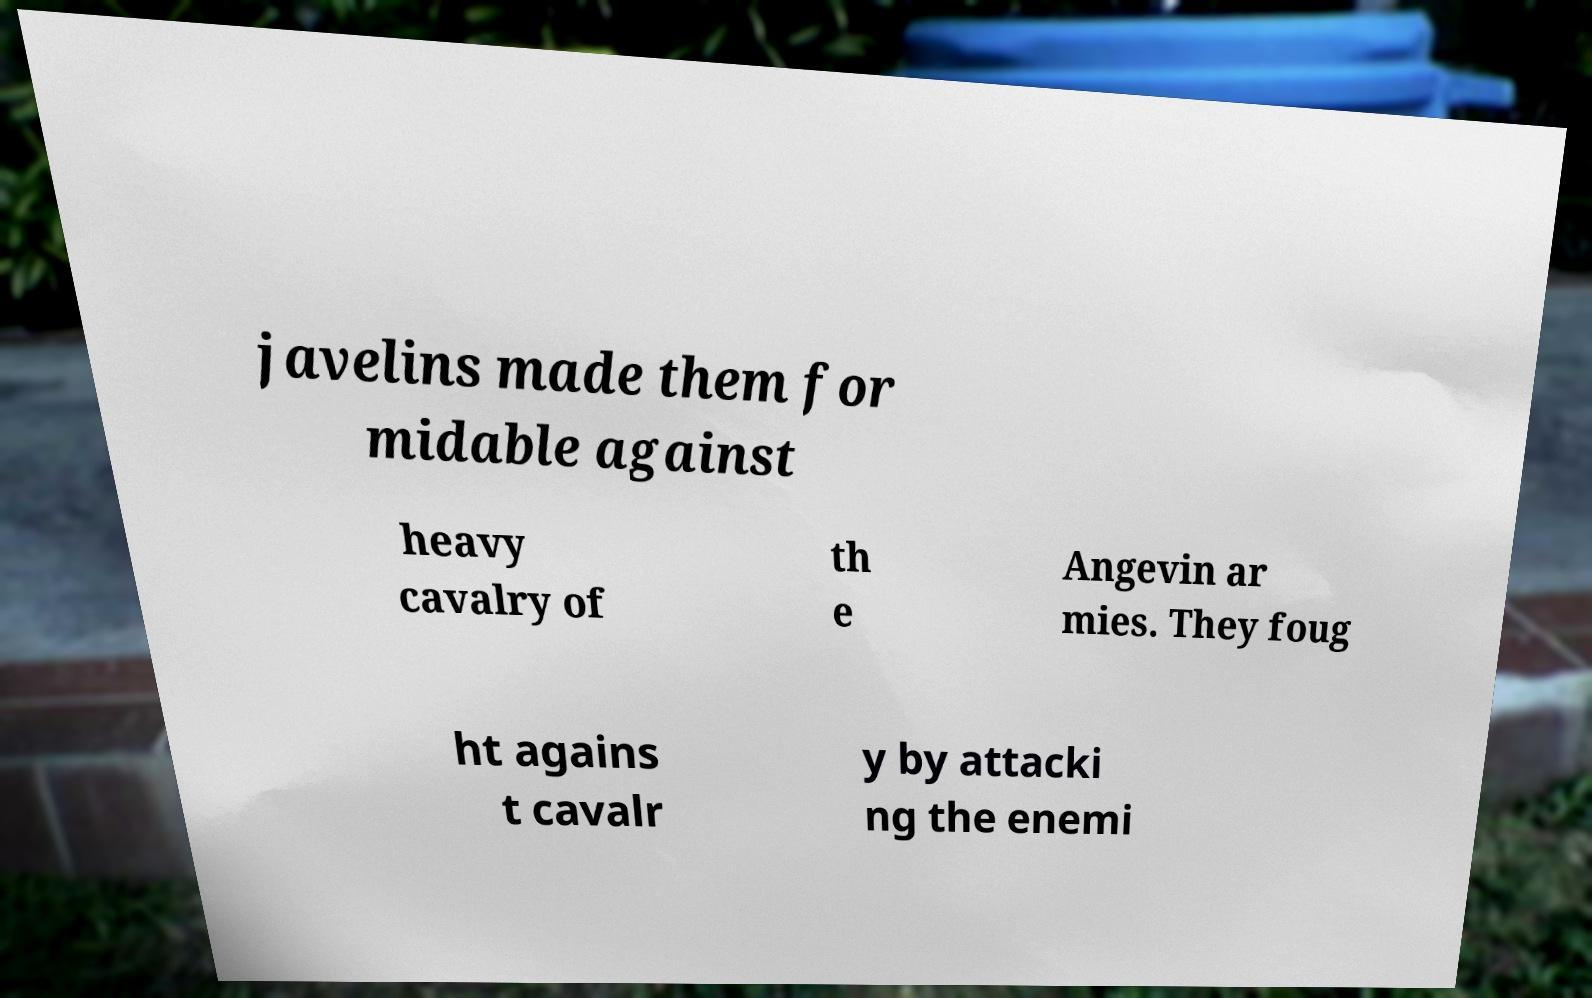Can you accurately transcribe the text from the provided image for me? javelins made them for midable against heavy cavalry of th e Angevin ar mies. They foug ht agains t cavalr y by attacki ng the enemi 